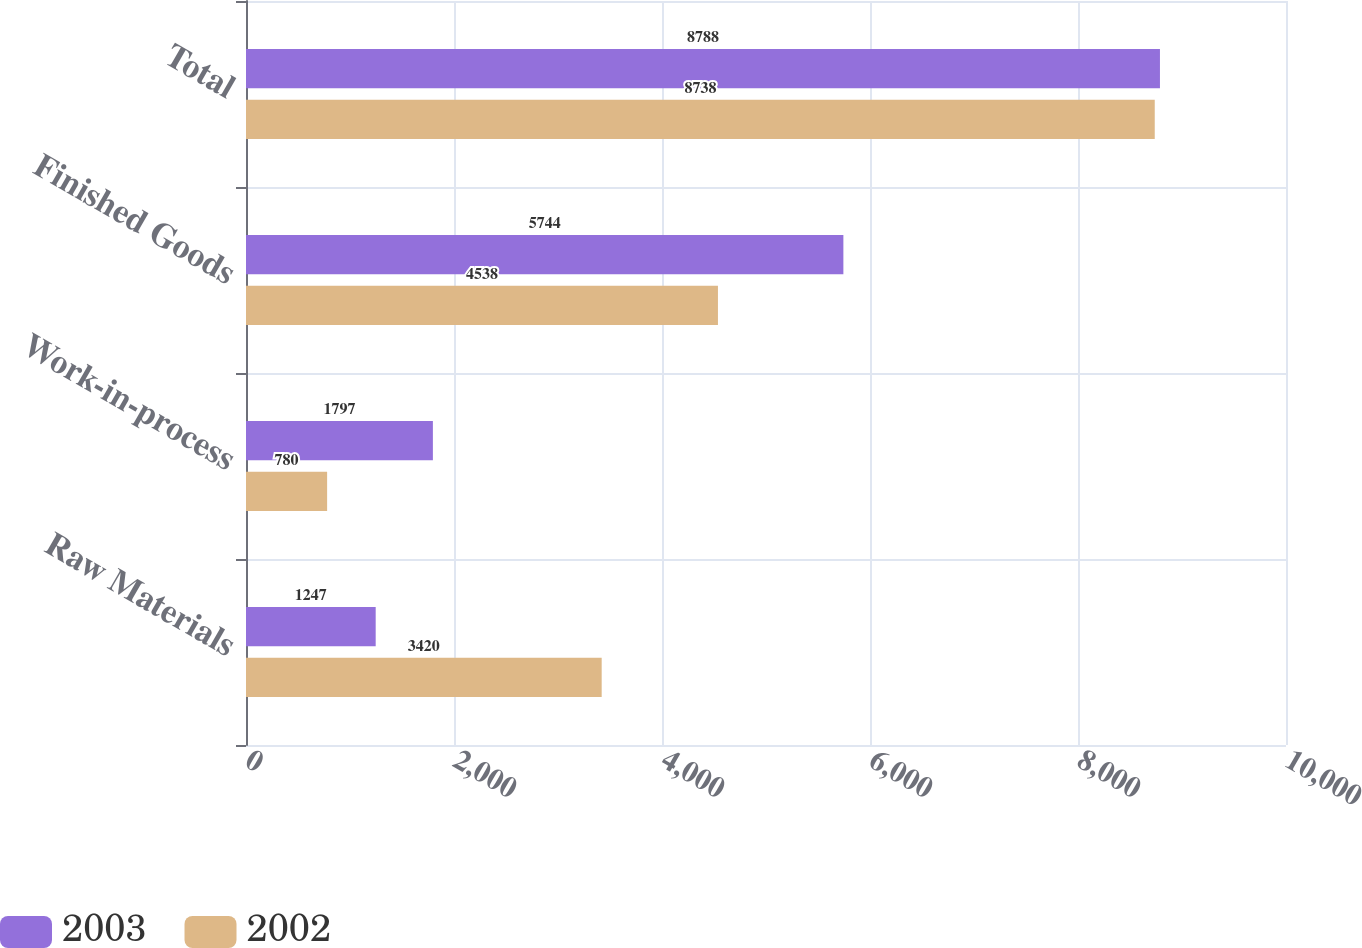<chart> <loc_0><loc_0><loc_500><loc_500><stacked_bar_chart><ecel><fcel>Raw Materials<fcel>Work-in-process<fcel>Finished Goods<fcel>Total<nl><fcel>2003<fcel>1247<fcel>1797<fcel>5744<fcel>8788<nl><fcel>2002<fcel>3420<fcel>780<fcel>4538<fcel>8738<nl></chart> 